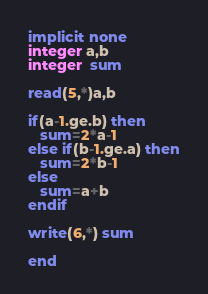Convert code to text. <code><loc_0><loc_0><loc_500><loc_500><_FORTRAN_>implicit none
integer a,b
integer  sum

read(5,*)a,b

if(a-1.ge.b) then
   sum=2*a-1
else if(b-1.ge.a) then
   sum=2*b-1
else
   sum=a+b
endif

write(6,*) sum

end</code> 